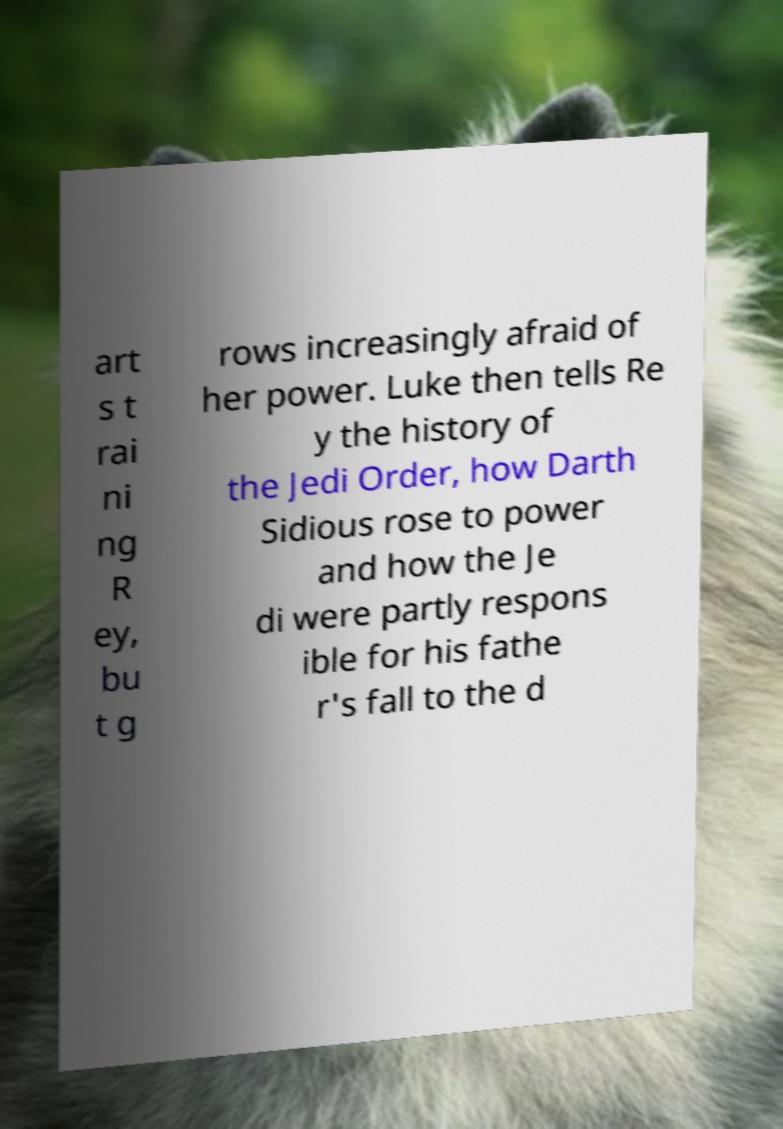Please read and relay the text visible in this image. What does it say? art s t rai ni ng R ey, bu t g rows increasingly afraid of her power. Luke then tells Re y the history of the Jedi Order, how Darth Sidious rose to power and how the Je di were partly respons ible for his fathe r's fall to the d 